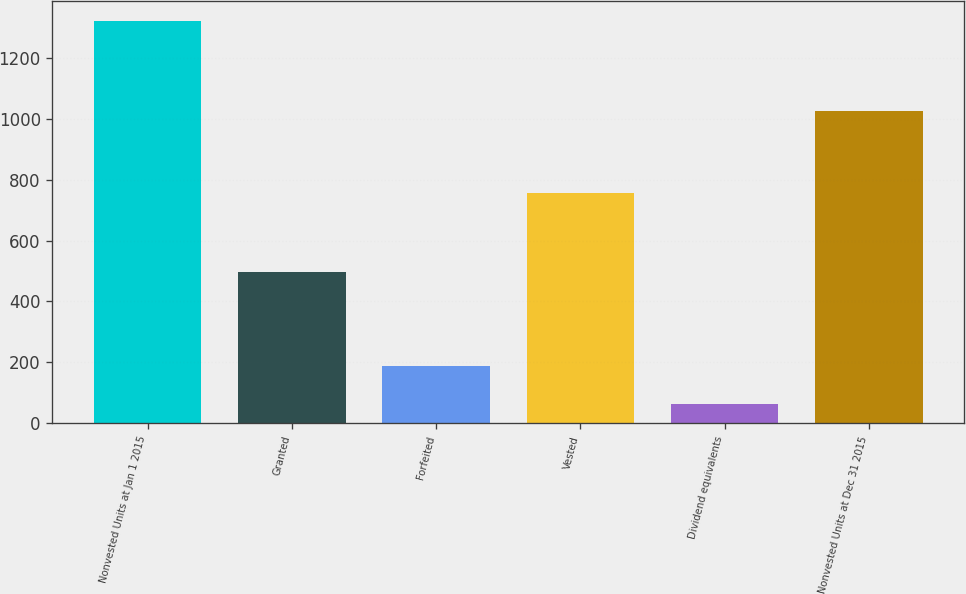Convert chart to OTSL. <chart><loc_0><loc_0><loc_500><loc_500><bar_chart><fcel>Nonvested Units at Jan 1 2015<fcel>Granted<fcel>Forfeited<fcel>Vested<fcel>Dividend equivalents<fcel>Nonvested Units at Dec 31 2015<nl><fcel>1322<fcel>496<fcel>188<fcel>756<fcel>62<fcel>1025<nl></chart> 